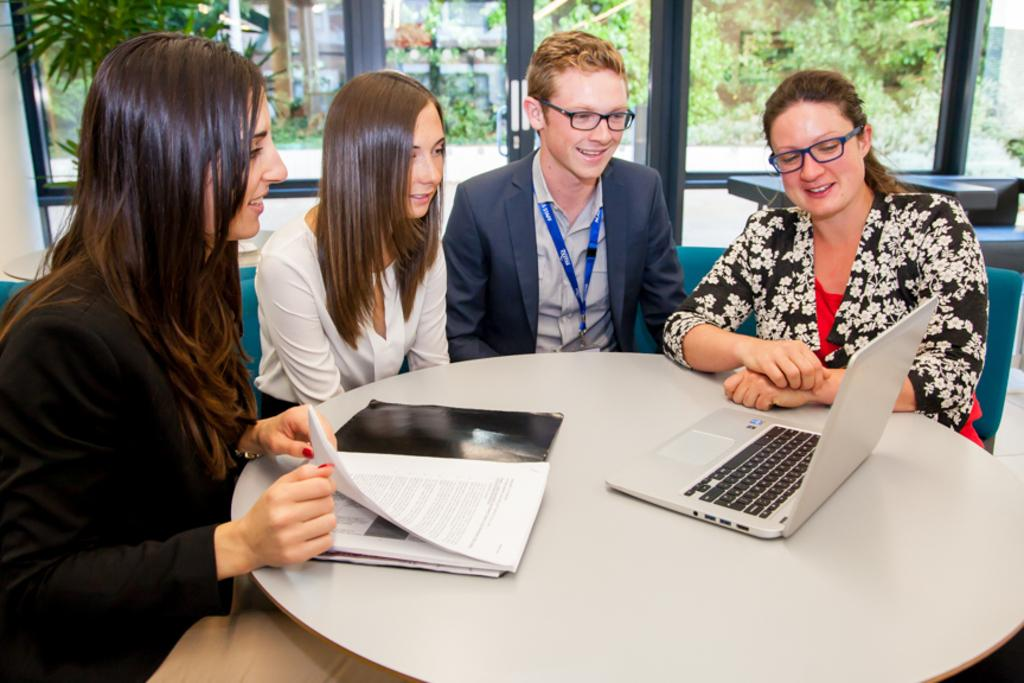How many people are in the image? There are multiple persons in the image. What are the persons doing in the image? The persons are sitting around a table. What objects can be seen on the table? There is a file and a laptop on the table. What can be seen in the background of the image? There are windows, trees, and a house in the background of the image. What type of story is being told by the persons in the image? There is no indication in the image that the persons are telling a story. What idea is being discussed by the persons in the image? The image does not provide any information about the topic of discussion among the persons. 